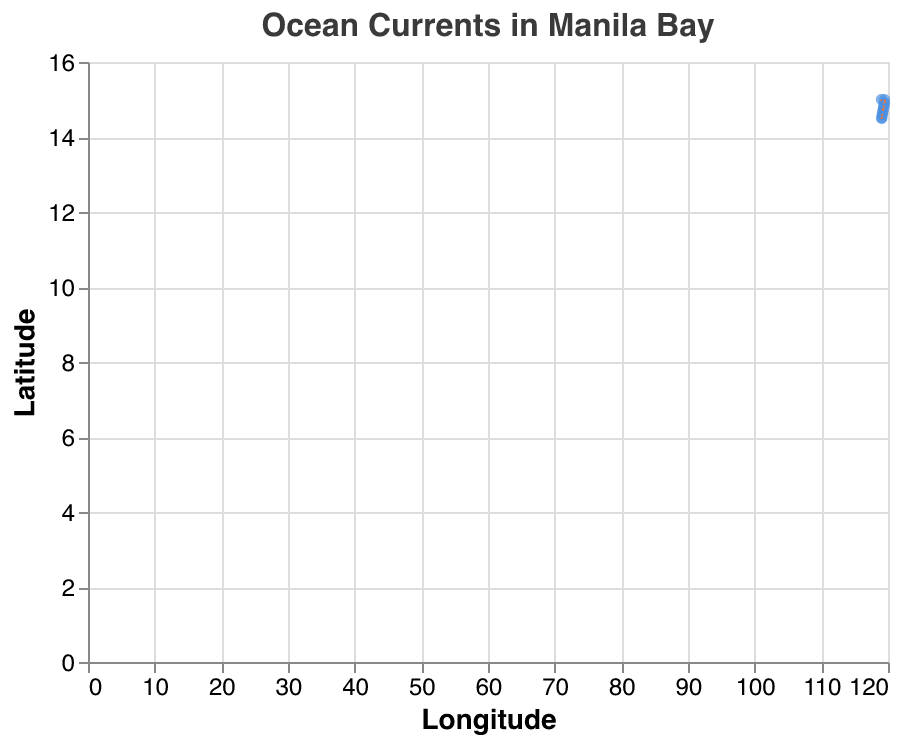What is the title of the figure? The title is indicated at the top of the figure. It reads "Ocean Currents in Manila Bay".
Answer: Ocean Currents in Manila Bay What are the axis labels in the figure? The x-axis is labeled "Longitude" and the y-axis is labeled "Latitude".
Answer: Longitude and Latitude How many data points are displayed in the figure? Each data point is represented by a blue dot. Counting these points in the figure gives a total of 12 data points.
Answer: 12 Which months show currents with negative U components? The tooltip for each vector shows the U and V components. The months with negative U components can be found by checking each vector's U value. These months are March, September, August, and December.
Answer: March, September, August, December Which month has the strongest positive U component, and what is its value? By reviewing the tooltips, the strongest positive U component is 0.4, which occurs in July.
Answer: July, 0.4 Which vector has the largest total magnitude, and what month does it correspond to? To find the vector with the largest magnitude, calculate √(u^2 + v^2) for each (u, v) pair and identify the largest value. This largest magnitude is found in July, with u=0.4 and v=0.2, resulting in a magnitude of √(0.4^2 + 0.2^2) = 0.447.
Answer: July How many vectors point predominantly northward (positive V component)? Check each vector's V component; if positive, it points northward. The months with positive V are May, February, April, June, and October.
Answer: 5 In which months do the ocean currents have a southward (negative V component) direction? The tooltips provide the V component. The months with a negative V component are January, March, August, November, and December.
Answer: January, March, August, November, December Which two months show the most southernly directed currents, and what are their V values? To determine the southernmost direction, look for the largest negative V values. These occur in November (-0.3) and December (-0.2).
Answer: November (-0.3), December (-0.2) In which months do the currents have a westward direction (negative U component)? By examining the provided U components, the months with negative U values are March, September, August, and December.
Answer: March, September, August, December 